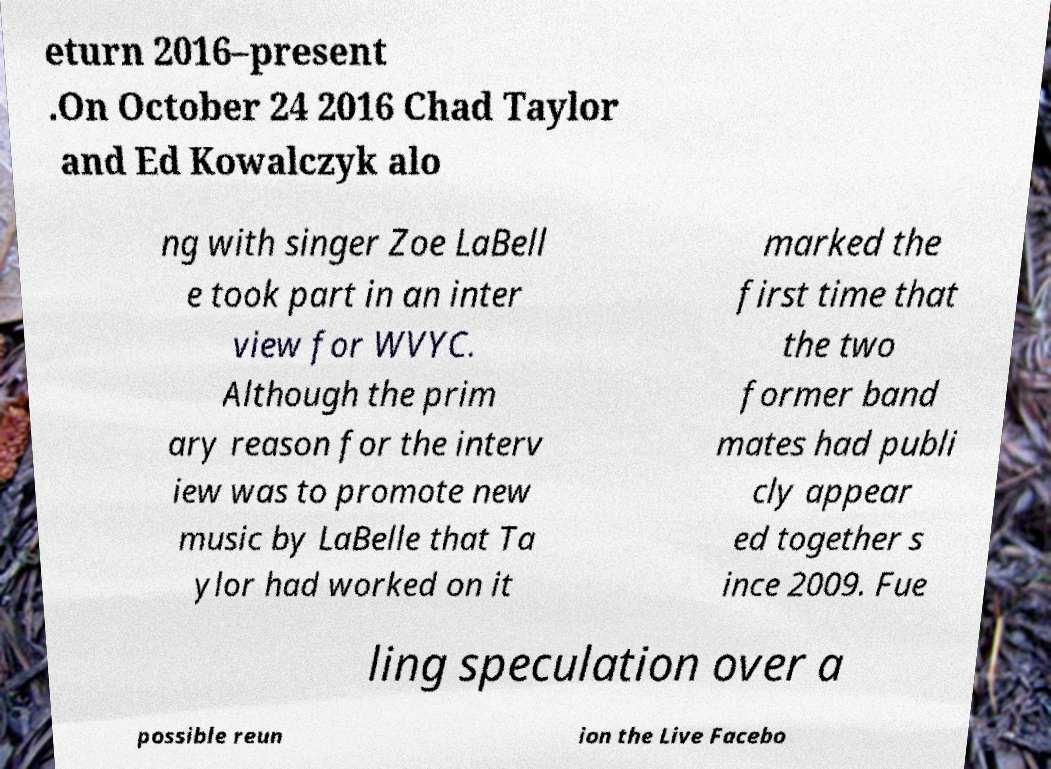What messages or text are displayed in this image? I need them in a readable, typed format. eturn 2016–present .On October 24 2016 Chad Taylor and Ed Kowalczyk alo ng with singer Zoe LaBell e took part in an inter view for WVYC. Although the prim ary reason for the interv iew was to promote new music by LaBelle that Ta ylor had worked on it marked the first time that the two former band mates had publi cly appear ed together s ince 2009. Fue ling speculation over a possible reun ion the Live Facebo 